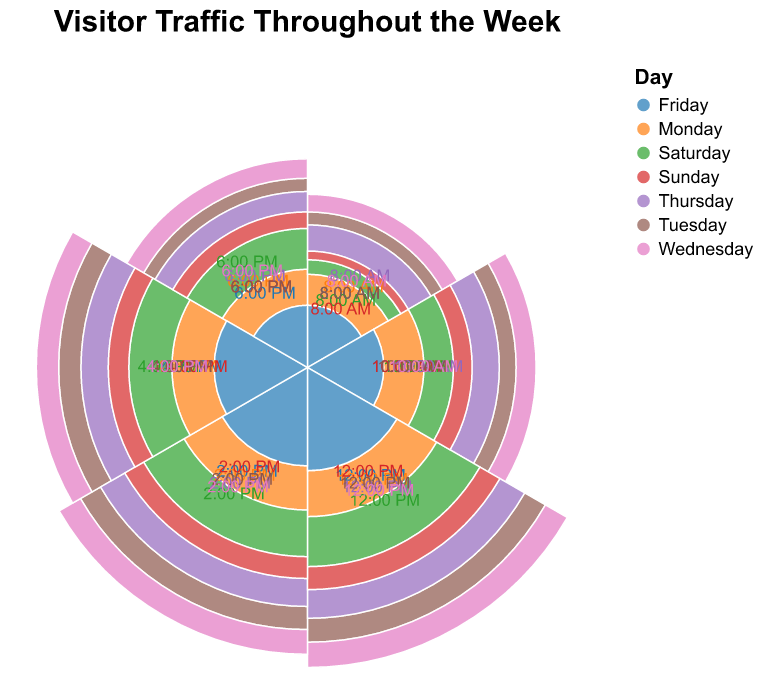What is the peak visitor count on Wednesday? Look for the highest "Visitors" value on Wednesday. The peak visitor count for Wednesday is 75, which occurs at 12:00 PM.
Answer: 75 At what time does the visitor count peak on Saturday? Identify the time with the highest "Visitors" value on Saturday. The peak visitor count on Saturday is at 12:00 PM with 90 visitors.
Answer: 12:00 PM How does the visitor count on Monday at 10:00 AM compare to that on Monday at 6:00 PM? Compare the "Visitors" count for Monday at 10:00 AM (40 visitors) with Monday at 6:00 PM (30 visitors). The visitor count at 10:00 AM is higher than at 6:00 PM.
Answer: Higher Which day has the lowest visitor count at 8:00 AM? Look at the "Visitors" count at 8:00 AM for each day of the week. Sunday has the lowest visitor count at 8:00 AM with 10 visitors.
Answer: Sunday What's the sum of visitor counts on Tuesday from 12:00 PM to 6:00 PM? Add the visitor counts for Tuesday at 12:00 PM (65), 2:00 PM (60), 4:00 PM (55), and 6:00 PM (25). The sum is 65 + 60 + 55 + 25 = 205.
Answer: 205 When is the busiest time of day throughout the entire week? Check for the highest "Visitors" value across all times and days. The highest visitor count is 90 on Saturday at 12:00 PM.
Answer: Saturday, 12:00 PM Compare the trend in visitor counts from 8:00 AM to 6:00 PM on Friday. Check "Visitors" values for each time slot on Friday: 8:00 AM (20), 10:00 AM (30), 12:00 PM (55), 2:00 PM (50), 4:00 PM (45), and 6:00 PM (20). The counts increase from 8:00 AM to 12:00 PM, then decrease until 6:00 PM.
Answer: Increase until 12:00 PM, then decrease Which day has the smallest range of visitor counts? Calculate the range (max - min) of visitor counts for each day and identify the smallest one. Monday has a range of 35 (60 - 25).
Answer: Monday What is the average visitor count at 4:00 PM across all days? Sum the visitor counts for 4:00 PM across all days and divide by 7. The total is 50 + 55 + 60 + 60 + 45 + 70 + 40 = 380. Average is 380 / 7 ≈ 54.29.
Answer: 54.29 Which two days have the most similar visitor counts at 2:00 PM? Check "Visitors" at 2:00 PM for all days and identify the two closest counts. Wednesday (70) and Thursday (65) are the most similar with a difference of 5.
Answer: Wednesday and Thursday 